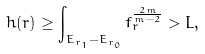Convert formula to latex. <formula><loc_0><loc_0><loc_500><loc_500>h ( r ) \geq \int _ { E _ { r _ { 1 } } - E _ { r _ { 0 } } } f _ { r } ^ { \frac { 2 m } { m - 2 } } > L ,</formula> 